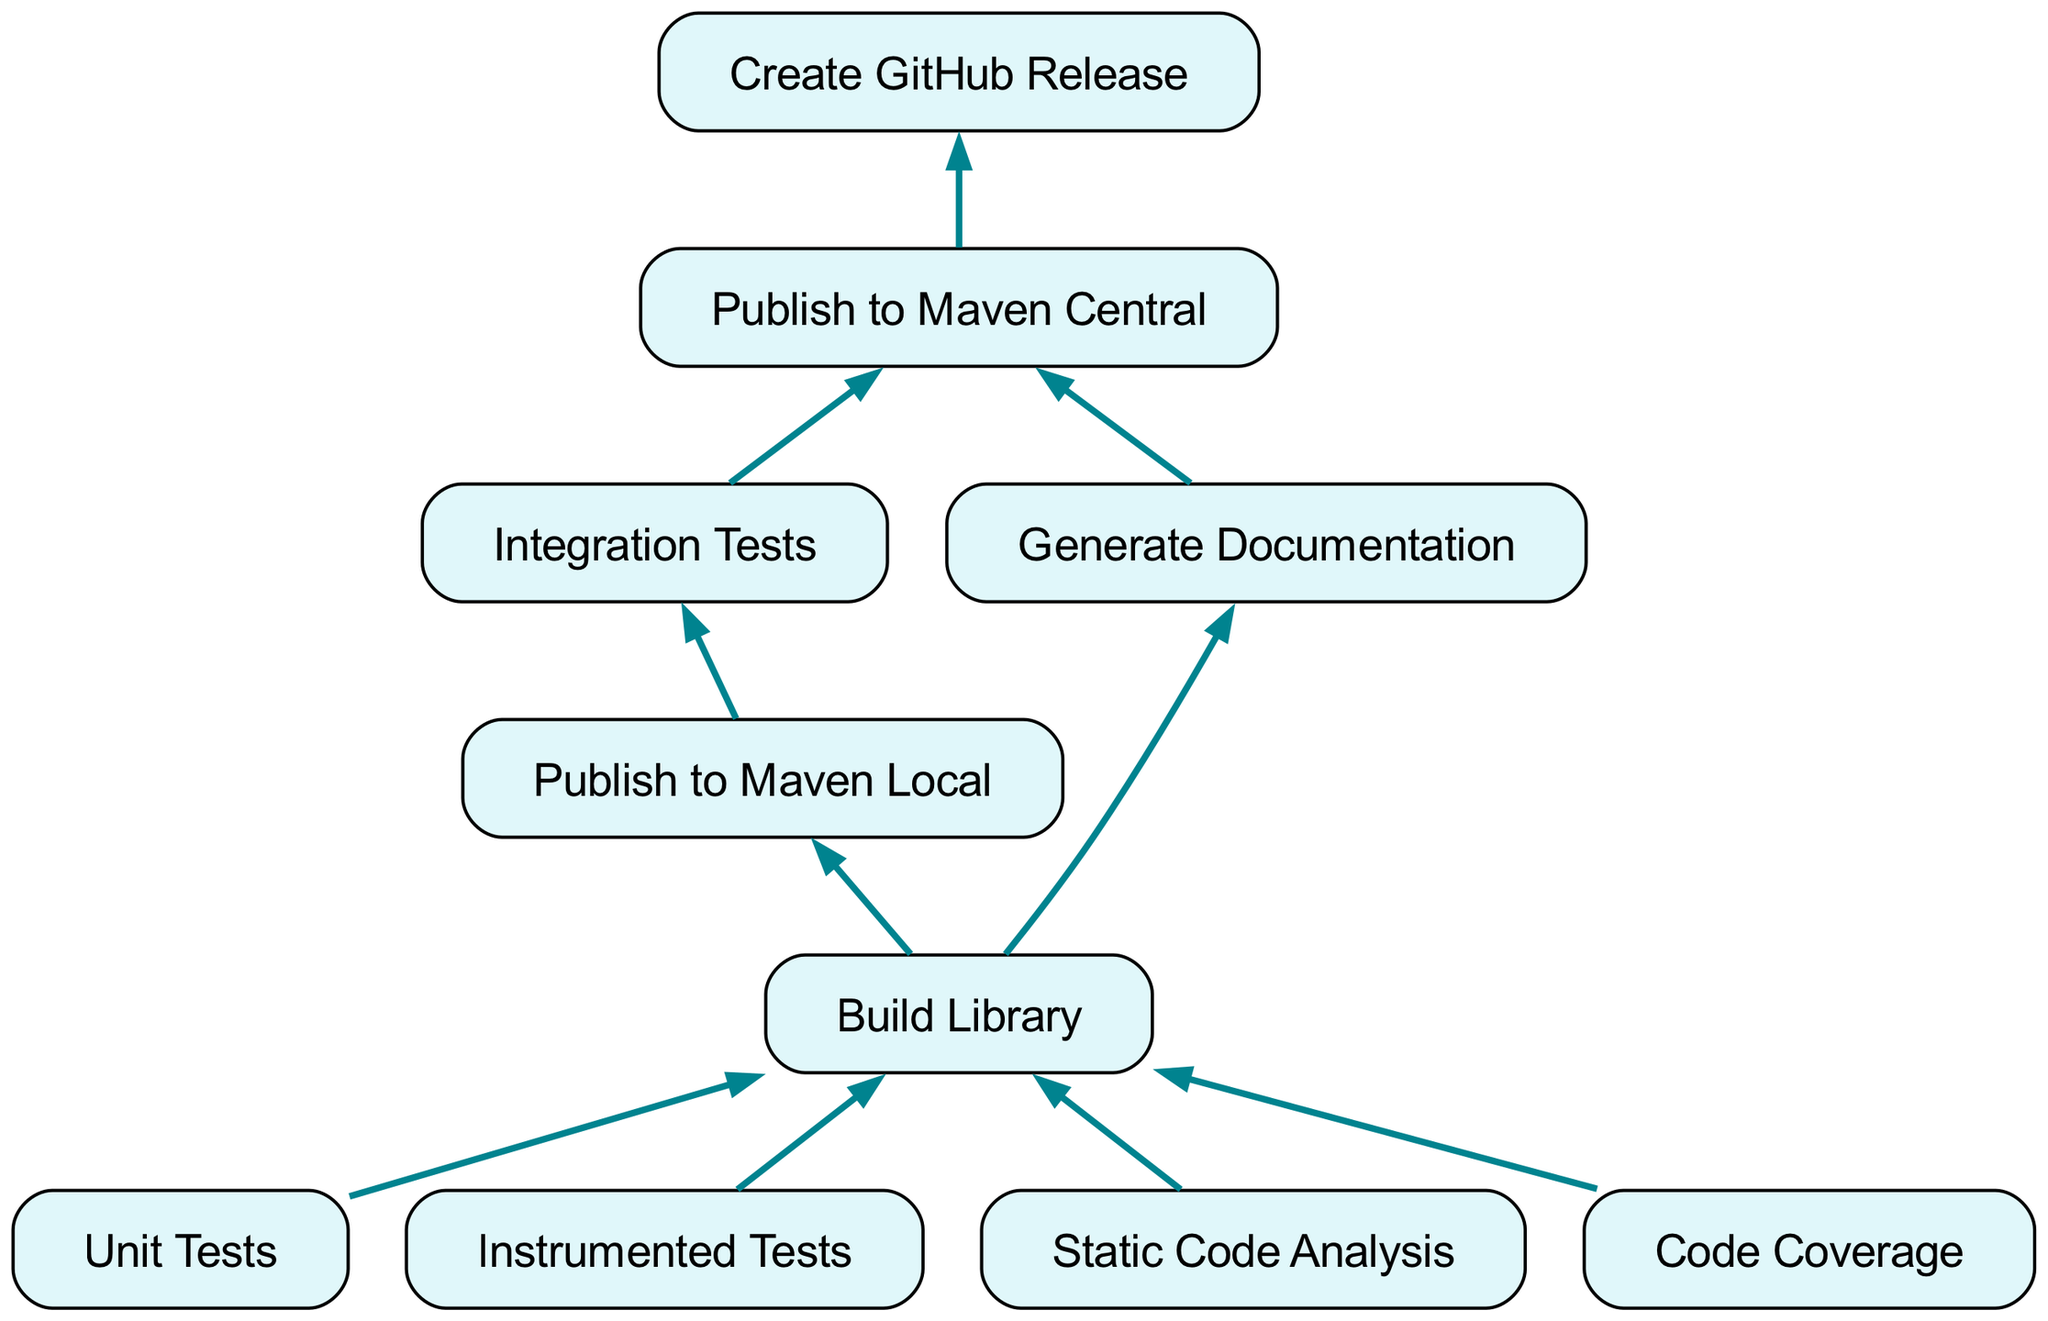What are the four primary tests performed before building the library? The diagram lists four tests prior to the "Build Library" step: Unit Tests, Instrumented Tests, Static Code Analysis, and Code Coverage. These are the foundational quality assurance steps to ensure the library functions correctly and meets standards before further deployment.
Answer: Unit Tests, Instrumented Tests, Static Code Analysis, Code Coverage Which node comes after "Publish to Maven Local"? The diagram shows "Integration Tests" as the direct next step following "Publish to Maven Local." This indicates that after the library is published locally, integration tests are executed to ensure everything works together as expected.
Answer: Integration Tests How many nodes are there in total in the pipeline? To find the total number of nodes, each unique node in the diagram must be counted. The nodes are: Unit Tests, Instrumented Tests, Static Code Analysis, Code Coverage, Build Library, Publish to Maven Local, Integration Tests, Generate Documentation, Publish to Maven Central, and Create GitHub Release, totaling ten nodes.
Answer: Ten What is the final step in the CI/CD pipeline? The final node listed in the diagram is "Create GitHub Release." This indicates that after all previous steps—including testing and publishing—the last action taken is creating a release on GitHub, making the library available to users.
Answer: Create GitHub Release Which node precedes "Publish to Maven Central"? The diagram illustrates that "Integration Tests" and "Generate Documentation" both need to be completed before moving to "Publish to Maven Central," showing that both steps are essential for successful publication.
Answer: Integration Tests, Generate Documentation How many edges connect to "Build Library"? The diagram indicates that there are four edges connected to "Build Library," with each edge representing one of the tests—Unit Tests, Instrumented Tests, Static Code Analysis, and Code Coverage—leading into this node for building the library.
Answer: Four What is the relationship of "Generate Documentation" to "Build Library"? In the diagram, "Generate Documentation" is a child node of "Build Library," meaning that documentation is generated after the library is built and relies on the successful completion of the build process.
Answer: Child node What type of testing follows "Publish to Maven Local"? The diagram shows "Integration Tests" as the step that follows "Publish to Maven Local," indicating a focus on testing the integration of components after local publication.
Answer: Integration Tests 